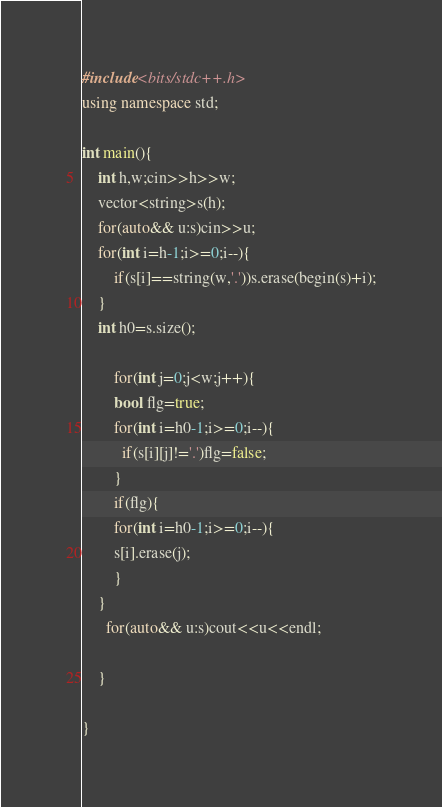<code> <loc_0><loc_0><loc_500><loc_500><_C++_>#include<bits/stdc++.h>
using namespace std;

int main(){
	int h,w;cin>>h>>w;
  	vector<string>s(h);
   	for(auto&& u:s)cin>>u;
  	for(int i=h-1;i>=0;i--){
    	if(s[i]==string(w,'.'))s.erase(begin(s)+i);
    }
    int h0=s.size();
  
    	for(int j=0;j<w;j++){
		bool flg=true;          
    	for(int i=h0-1;i>=0;i--){
          if(s[i][j]!='.')flg=false;
        }
    	if(flg){
        for(int i=h0-1;i>=0;i--){
        s[i].erase(j);
        }
    }
      for(auto&& u:s)cout<<u<<endl;     
      
    }
           
}
</code> 